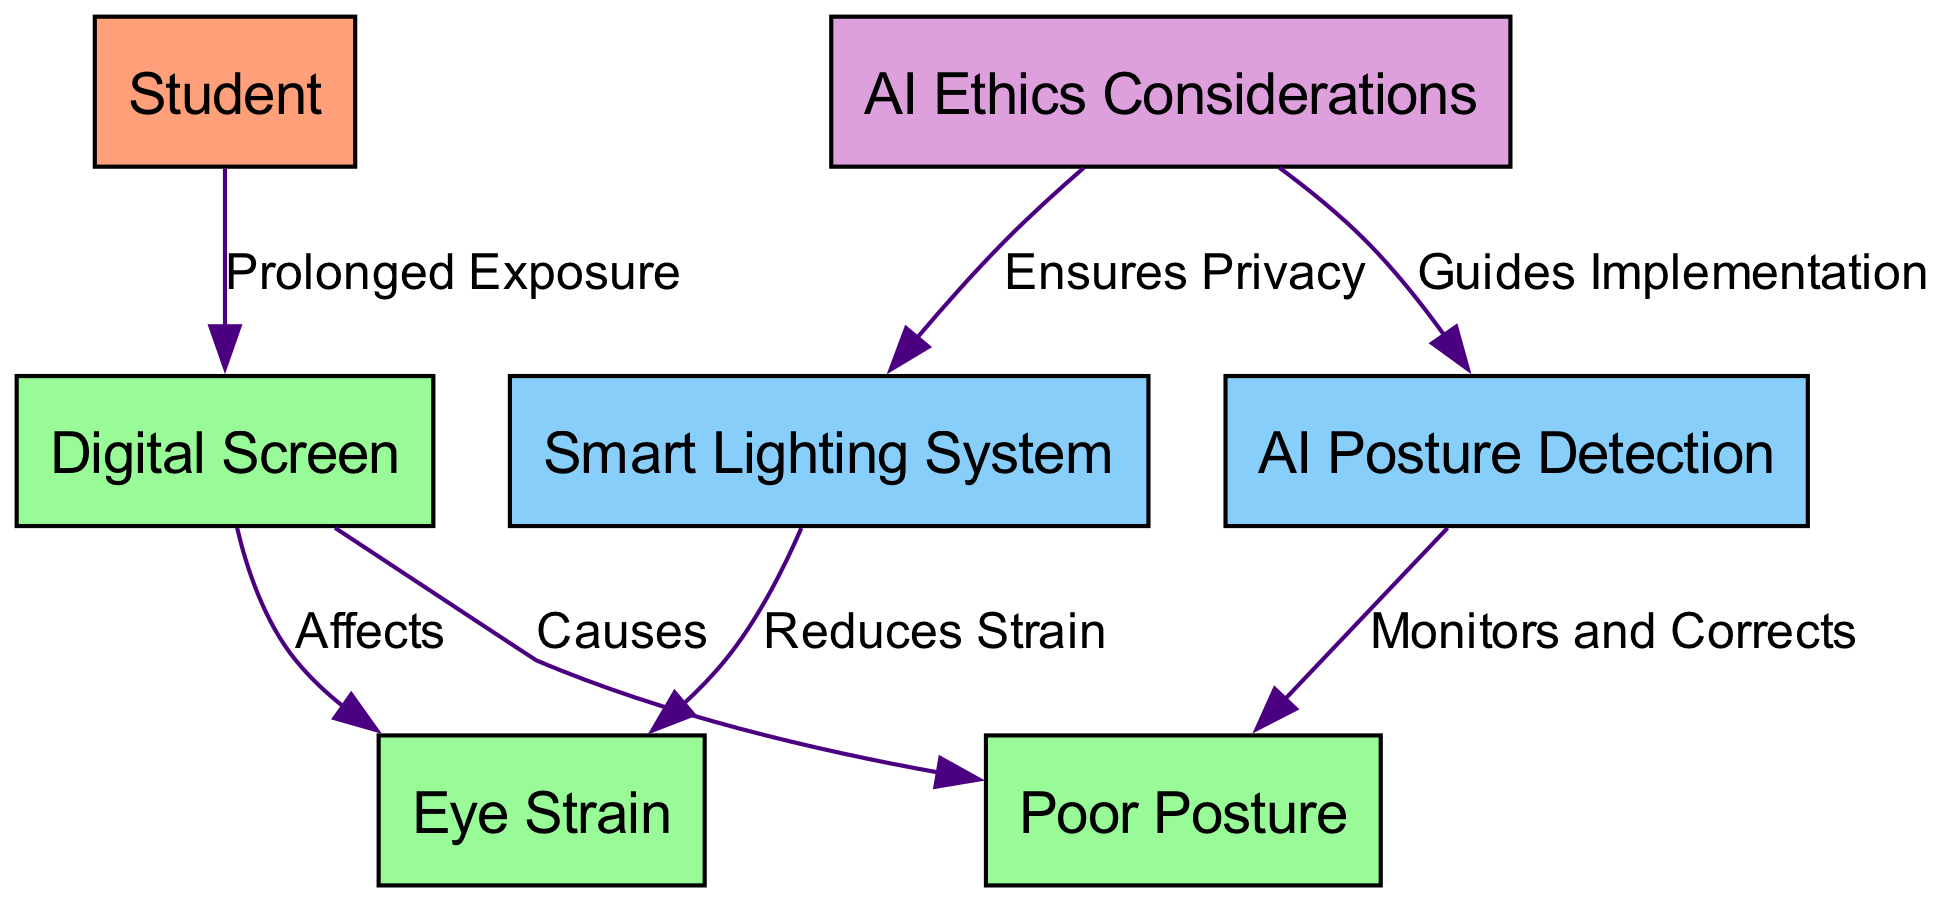What is the main subject node of the diagram? The main subject node in the diagram is "Student," which represents the primary focus of the impact analysis regarding screen time. This can easily be identified as it is the starting point of various connections leading to other effects, such as posture and eye health.
Answer: Student How many nodes are present in the diagram? By counting each unique entity represented in the diagram, we identify a total of six nodes: Student, Digital Screen, Poor Posture, Eye Strain, AI Posture Detection, and Smart Lighting System. Therefore, the total number of nodes is determined through direct observation.
Answer: 6 What effect does the "Digital Screen" have on "Eye Strain"? The relationship is denoted in the diagram with a directional edge labeled "Affects," indicating that the Digital Screen is causing Eye Strain. This connection clearly shows the direct impact of prolonged screen time on eye health.
Answer: Affects Which node is connected to "Poor Posture"? The node "AI Posture Detection" is connected to "Poor Posture" and it indicates the way AI can be used to monitor and correct posture-related issues caused by prolonged screen time. This relationship shows a technological solution to mitigate the effect of poor posture.
Answer: AI Posture Detection What do "Smart Lighting System" and "Eye Strain" have in common? Both nodes are connected, with the edge indicating that the Smart Lighting System helps to "Reduces Strain" on the eyes. Thus, they share a relationship where the technology aims to alleviate the negative effects caused by screen use on eye health.
Answer: Reduces Strain What guides the implementation of "AI Posture Detection"? The diagram shows that "AI Ethics Considerations" guides the implementation of "AI Posture Detection," suggesting that ethical concerns shape the way AI technologies are developed and utilized in monitoring student posture. This underscores the importance of addressing ethical implications in technological advancements.
Answer: Guides Implementation How is "Smart Lighting System" related to "AI Ethics Considerations"? The relationship shown in the diagram indicates that "AI Ethics Considerations" also "Ensures Privacy" concerning the use of Smart Lighting Systems, highlighting that the implementation of these technologies must consider ethical privacy issues to protect users.
Answer: Ensures Privacy What causes "Poor Posture" as depicted in the diagram? The cause of Poor Posture is indicated by the directional edge from "Digital Screen," which is labeled "Causes," illustrating that prolonged exposure to digital screens directly leads to poor posture among students.
Answer: Causes 